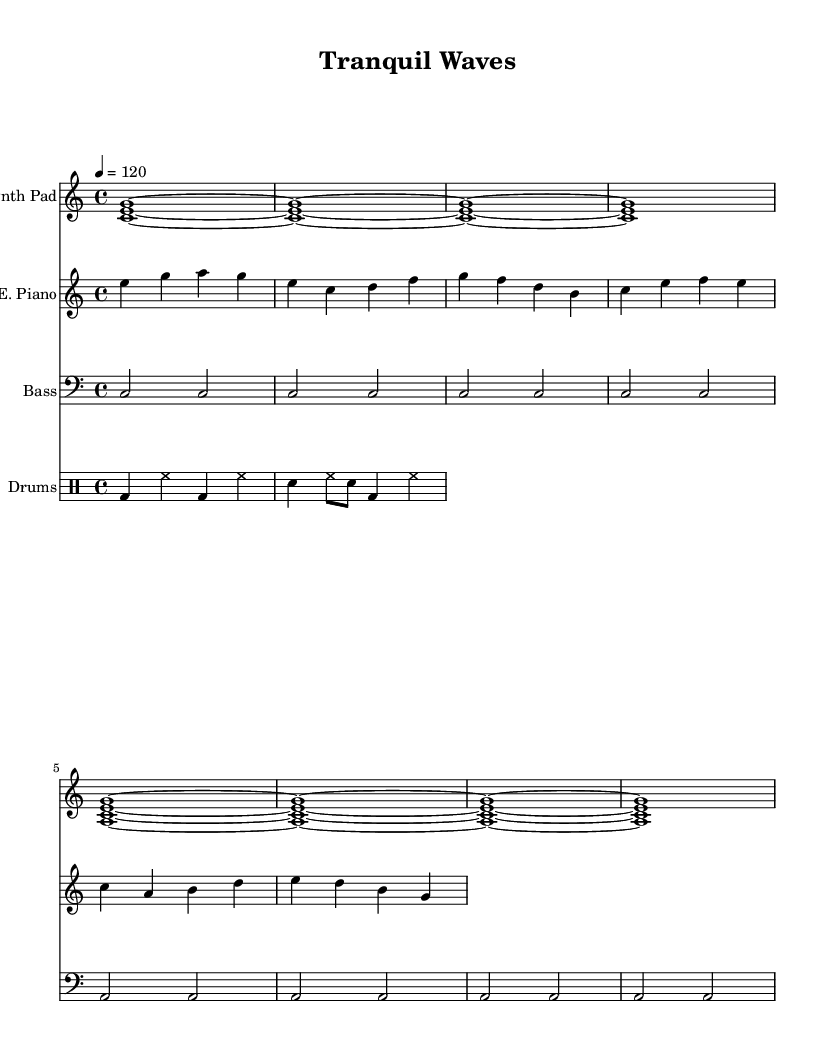What is the key signature of this music? The key signature is C major, which has no sharps or flats.
Answer: C major What is the time signature of this music? The time signature is indicated by the symbol "4/4," meaning there are four beats in each measure and the quarter note gets one beat.
Answer: 4/4 What is the tempo marking of this piece? The tempo marking is indicated by "4 = 120," meaning there are 120 beats per minute, and each quarter note receives one beat.
Answer: 120 How many measures are in the synth pad section? The synth pad section consists of 8 measures, as indicated by the repeated patterns in the notation.
Answer: 8 What is the rhythmic pattern of the drums? The rhythmic pattern of the drums consists of bass drum and hi-hat patterns combined with snare accents, featuring both quarter and eighth notes in a repeating pattern.
Answer: Bass drum, hi-hat, snare What type of instrumentation is featured in this piece? The piece features electronic instruments such as a synth pad, electric piano, bass, and drums, which are common in deep house music.
Answer: Synth pad, electric piano, bass, drums How does the bass complement the synth pad? The bass plays sustained notes that align with the harmonic changes of the synth pad, providing a foundation that complements the lush chords of the synth.
Answer: Sustained notes 